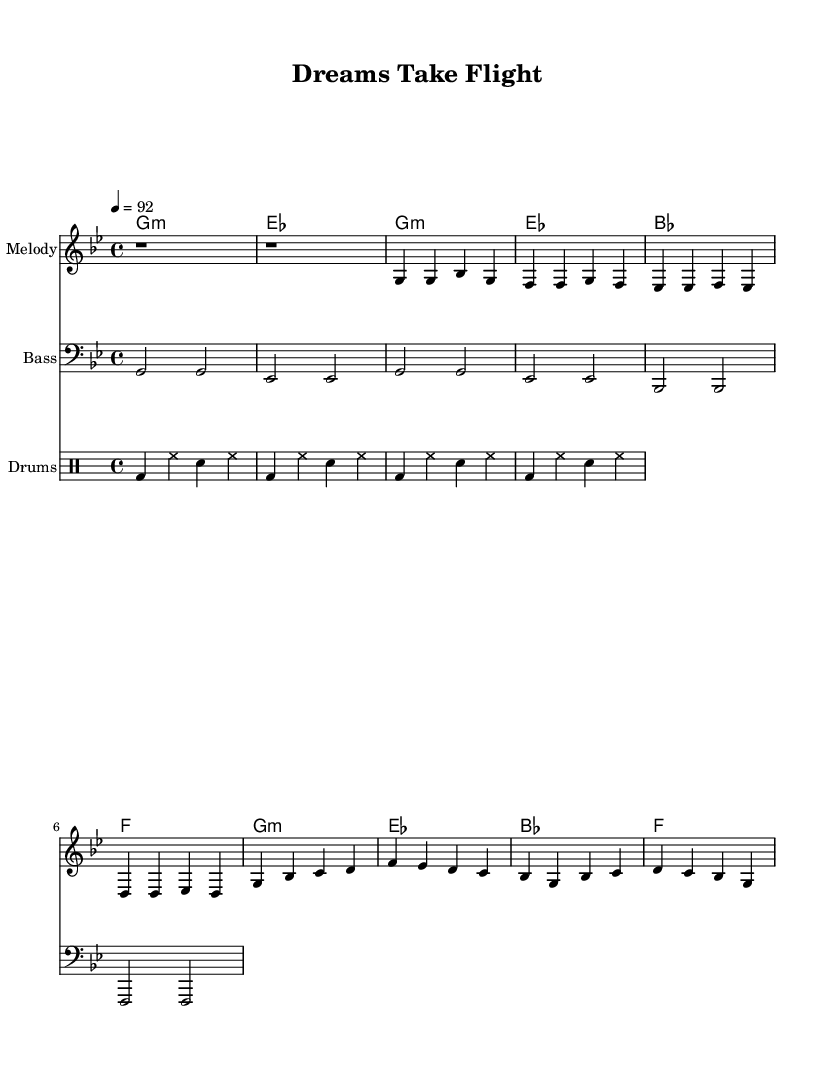What is the key signature of this music? The key signature is G minor, which has two flats (B flat and E flat). It can be identified by the symbol next to the clef in the sheet music.
Answer: G minor What is the time signature of this music? The time signature is 4/4, indicating that there are four beats per measure, and the quarter note gets one beat. This is shown at the beginning of the score.
Answer: 4/4 What is the tempo marking for this piece? The tempo is marked at 92 beats per minute, which is indicated by "4 = 92" in the sheet music. This tells performers how fast to play the piece.
Answer: 92 How many measures are in the verse section? The verse section contains four measures, as indicated by the phrasing and spacing of the notes within that part of the music.
Answer: Four measures What type of musical instrument is shown for the melody? The instrument shown for the melody is a standard treble staff, which typically represents higher-pitched instruments such as flutes or violins.
Answer: Melody What makes this piece suitable for rap? This piece uses consistent rhythms and a repetitive structure typical of rap music, allowing for ease of lyric delivery and emphasizing the song's rhythm over melodic complexity.
Answer: Consistent rhythms Which chord is the first one played in the intro? The first chord played in the intro is G minor, noted at the beginning of the harmonies section in the sheet music.
Answer: G minor 